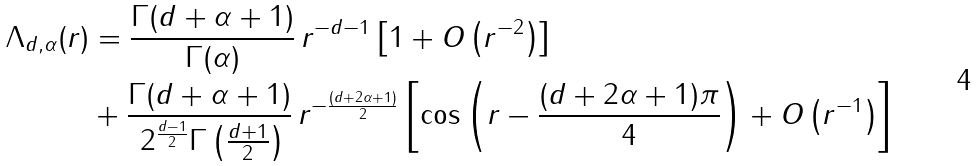Convert formula to latex. <formula><loc_0><loc_0><loc_500><loc_500>\Lambda _ { d , \alpha } ( r ) & = \frac { \Gamma ( d + \alpha + 1 ) } { \, \Gamma ( \alpha ) \, } \, r ^ { - d - 1 } \left [ 1 + O \left ( r ^ { - 2 } \right ) \right ] \\ & + \frac { \Gamma ( d + \alpha + 1 ) } { \, 2 ^ { \frac { d - 1 } { 2 } } \Gamma \left ( \frac { d + 1 } { 2 } \right ) } \, r ^ { - \frac { ( d + 2 \alpha + 1 ) } { 2 } } \left [ \cos \left ( r - \frac { ( d + 2 \alpha + 1 ) \pi } { 4 } \right ) + O \left ( r ^ { - 1 } \right ) \right ]</formula> 